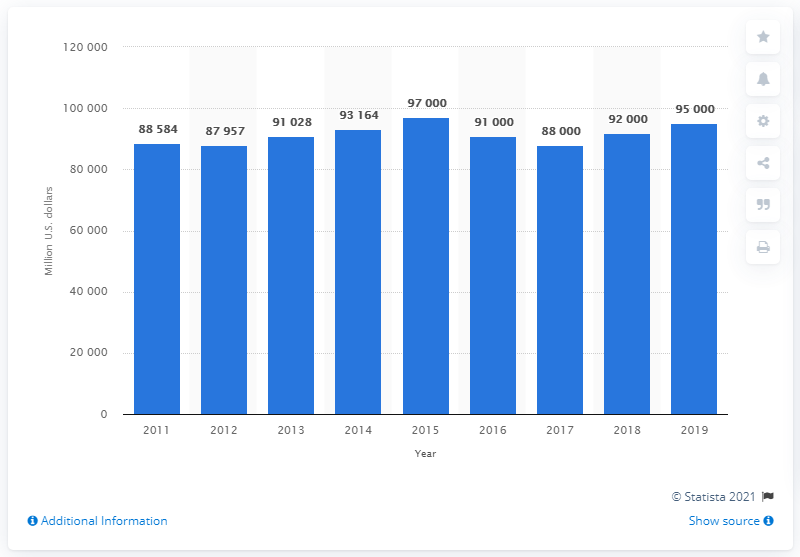Indicate a few pertinent items in this graphic. The total value of U.S. clothing imports from 2011 to 2019 was approximately 95,000. 